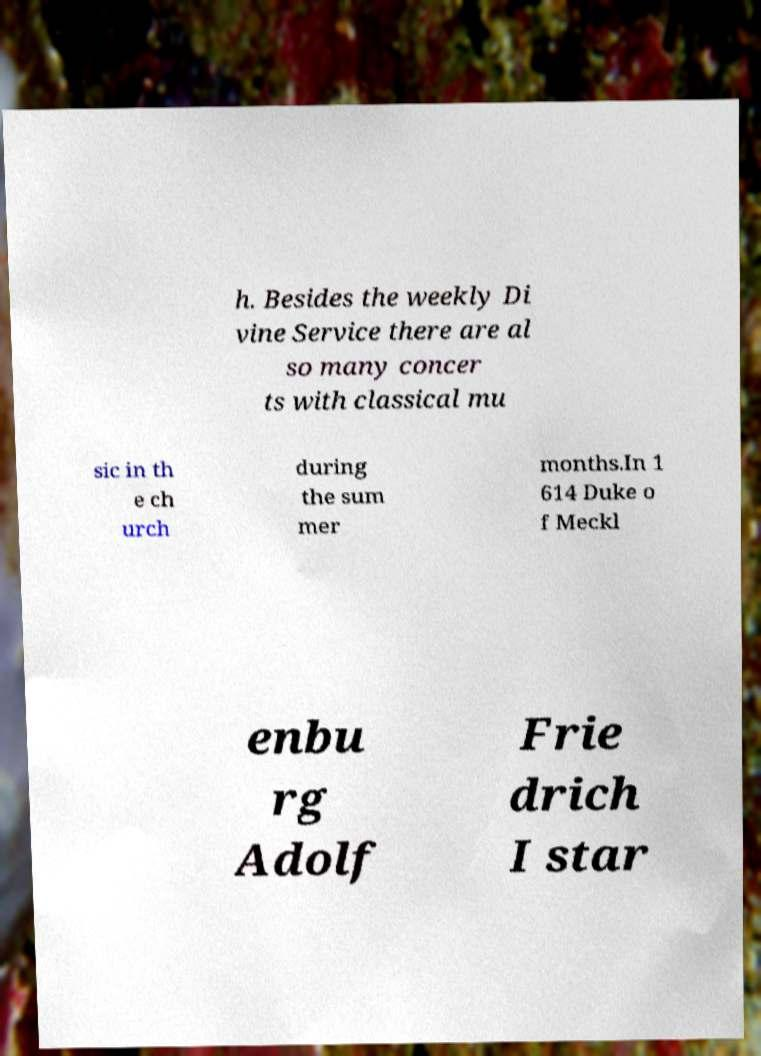Can you accurately transcribe the text from the provided image for me? h. Besides the weekly Di vine Service there are al so many concer ts with classical mu sic in th e ch urch during the sum mer months.In 1 614 Duke o f Meckl enbu rg Adolf Frie drich I star 